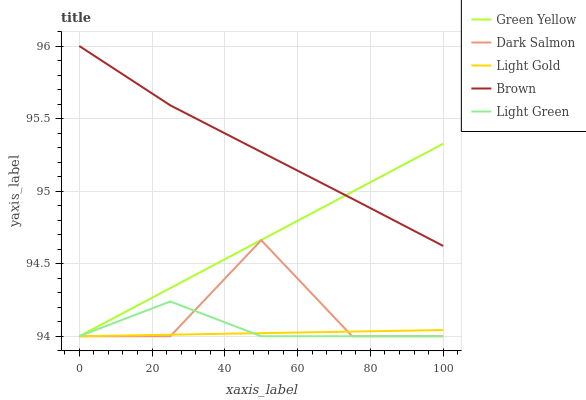Does Light Gold have the minimum area under the curve?
Answer yes or no. Yes. Does Brown have the maximum area under the curve?
Answer yes or no. Yes. Does Green Yellow have the minimum area under the curve?
Answer yes or no. No. Does Green Yellow have the maximum area under the curve?
Answer yes or no. No. Is Light Gold the smoothest?
Answer yes or no. Yes. Is Dark Salmon the roughest?
Answer yes or no. Yes. Is Green Yellow the smoothest?
Answer yes or no. No. Is Green Yellow the roughest?
Answer yes or no. No. Does Green Yellow have the lowest value?
Answer yes or no. Yes. Does Brown have the highest value?
Answer yes or no. Yes. Does Green Yellow have the highest value?
Answer yes or no. No. Is Light Gold less than Brown?
Answer yes or no. Yes. Is Brown greater than Light Gold?
Answer yes or no. Yes. Does Light Green intersect Dark Salmon?
Answer yes or no. Yes. Is Light Green less than Dark Salmon?
Answer yes or no. No. Is Light Green greater than Dark Salmon?
Answer yes or no. No. Does Light Gold intersect Brown?
Answer yes or no. No. 